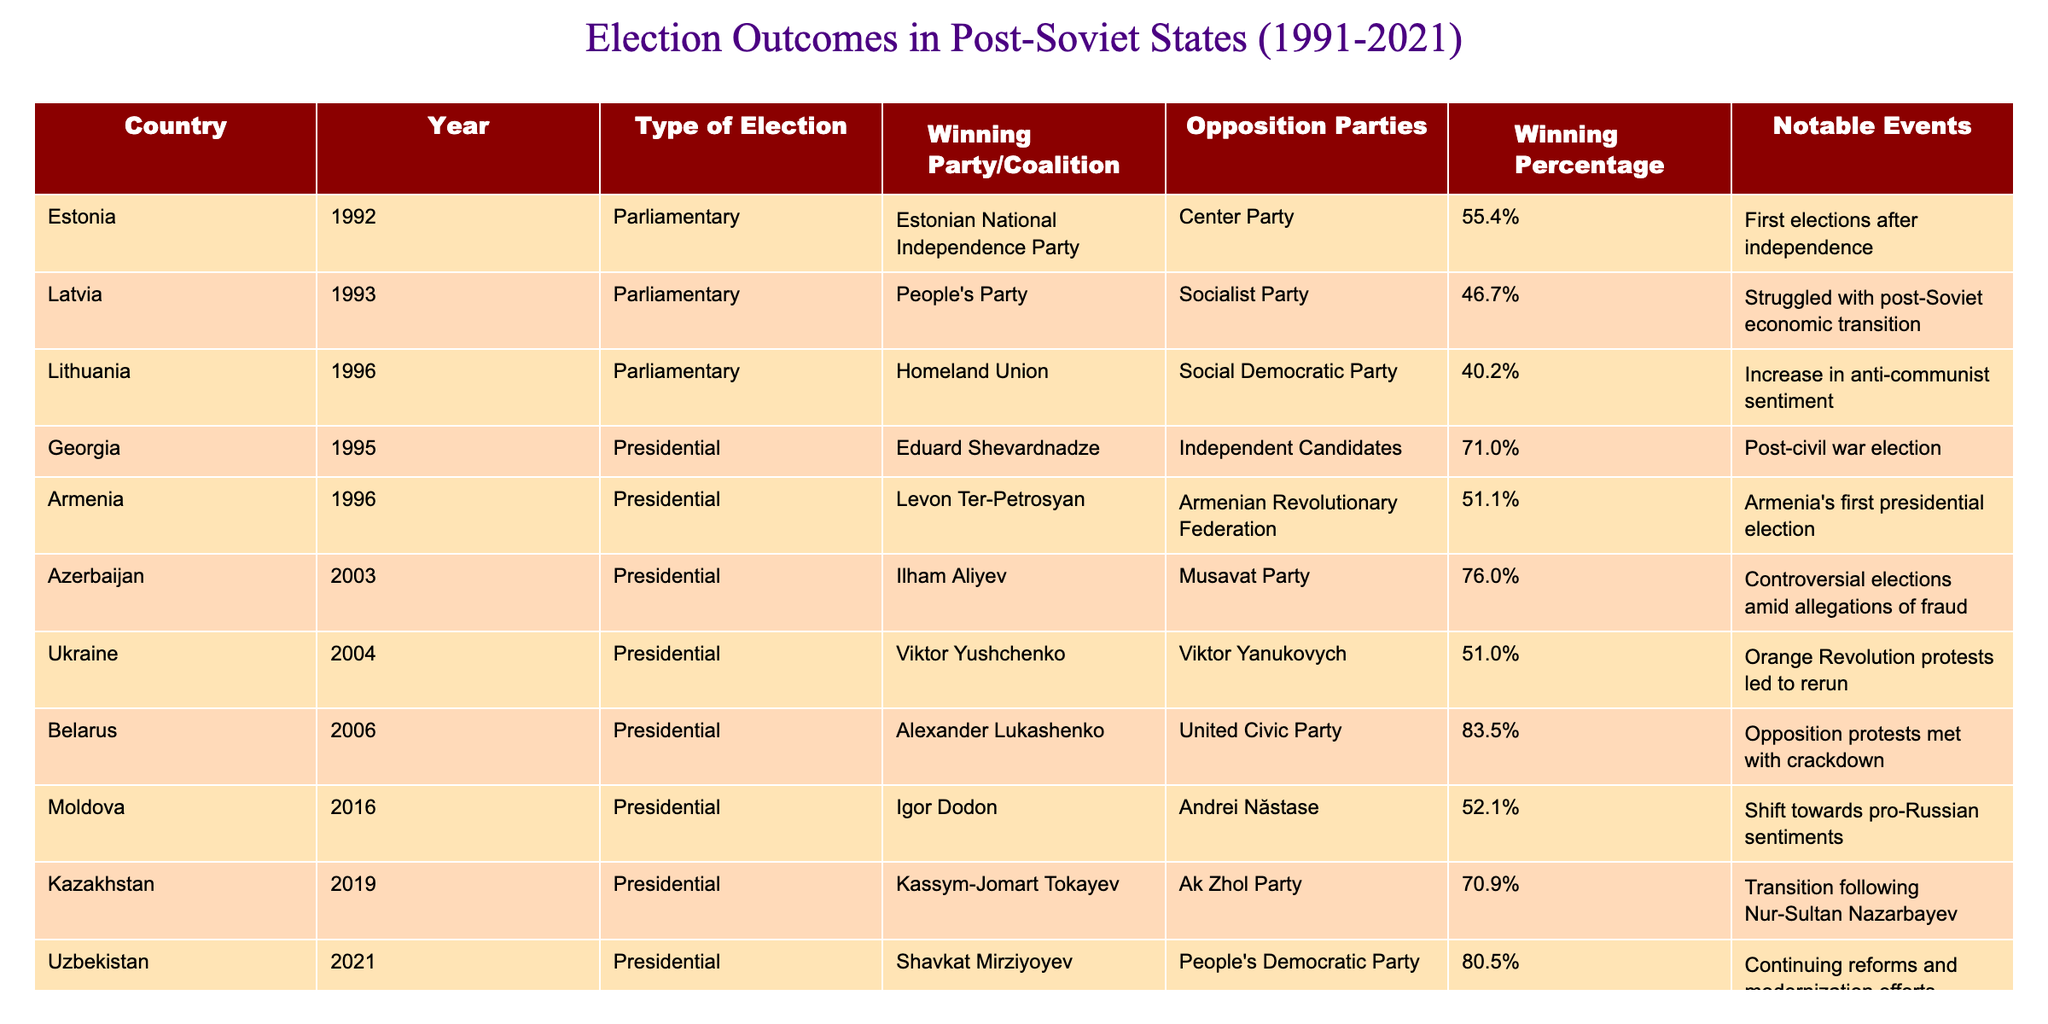What was the winning percentage for the Estonian National Independence Party in 1992? The table shows that the winning percentage for the Estonian National Independence Party in 1992 was 55.4%.
Answer: 55.4% Which country had the highest winning percentage for a presidential election? The table indicates that Uzbekistan in 2021 had the highest winning percentage for a presidential election at 80.5%.
Answer: Uzbekistan (80.5%) Did the winning party in Azerbaijan in 2003 secure a percentage above 75%? The table states that Ilham Aliyev, the winning party in Azerbaijan in 2003, secured 76.0%, which is indeed above 75%.
Answer: Yes How many countries had presidential elections between 1995 and 2006? From the table, the countries with presidential elections between 1995 and 2006 are Georgia (1995), Armenia (1996), Azerbaijan (2003), and Belarus (2006), totaling four countries.
Answer: 4 What is the average winning percentage of all presidential elections listed in the table? To find the average, we sum the winning percentages of the presidential elections: 71.0 + 51.1 + 76.0 + 51.0 + 83.5 + 52.1 + 70.9 + 80.5 =  576.1%. There are seven presidential elections, so the average is 576.1 / 7 = approximately 82.3%.
Answer: Approximately 82.3% Which winning party had the lowest winning percentage in legislative elections based on the provided data? The table indicates that the lowest winning percentage in legislative elections was 40.2% by the Homeland Union in Lithuania in 1996.
Answer: Homeland Union (40.2%) In which country did a political transition follow the winning election? The table indicates that Kazakhstan in 2019 had a transition following the election of Kassym-Jomart Tokayev, which was noted in the "Notable Events" column.
Answer: Kazakhstan What was the notable event during the presidential elections in Belarus in 2006? The "Notable Events" column states that the notable event during the Belarus presidential elections in 2006 was opposition protests met with a crackdown.
Answer: Opposition protests met with crackdown Identify the difference in winning percentages between the winning parties in Ukraine in 2004 and Latvia in 1993. The winning percentage for Viktor Yushchenko in Ukraine in 2004 was 51.0%, and for the People's Party in Latvia in 1993 was 46.7%. The difference is calculated as 51.0 - 46.7 = 4.3%.
Answer: 4.3% Which winning party had a noteworthy election event that involved the Orange Revolution? The table indicates that the winning party, Viktor Yushchenko in Ukraine in 2004, was associated with the Orange Revolution protests led to a rerun.
Answer: Viktor Yushchenko (Ukraine, 2004) Was there an instance of a presidential election resulting in a significant increase in anti-communist sentiment? Yes, the table states that Lithuania in 1996 experienced an increase in anti-communist sentiment during the presidential election.
Answer: Yes 